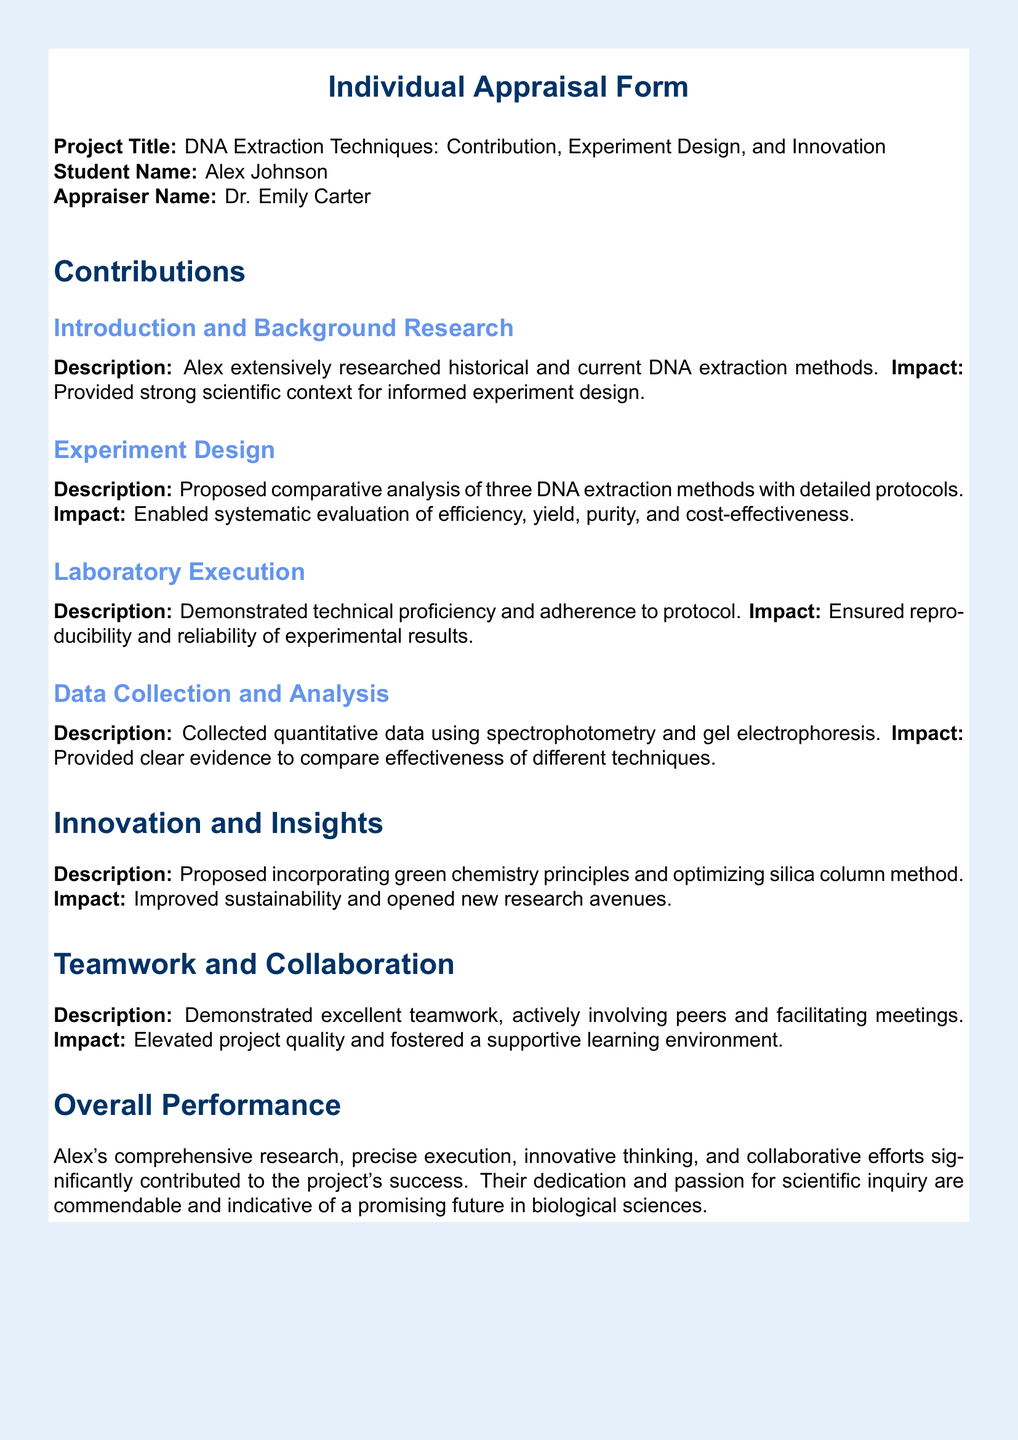What is the project title? The project title is mentioned at the beginning of the document as "DNA Extraction Techniques: Contribution, Experiment Design, and Innovation."
Answer: DNA Extraction Techniques: Contribution, Experiment Design, and Innovation Who is the student name? The document explicitly states the student name as "Alex Johnson."
Answer: Alex Johnson What does the Impact of Laboratory Execution describe? It describes ensuring reproducibility and reliability of experimental results, highlighting the importance of technical proficiency.
Answer: Ensured reproducibility and reliability of experimental results Which principles did Alex propose to incorporate? The document mentions incorporating "green chemistry principles."
Answer: Green chemistry principles Who was the appraiser? The appraiser's name is listed as "Dr. Emily Carter."
Answer: Dr. Emily Carter What was the main innovation suggested in the project? The main innovation mentioned is "optimizing silica column method," indicating an improvement in the extraction technique.
Answer: Optimizing silica column method What types of methods were analyzed in the experiment design? The document states that three DNA extraction methods were proposed for the comparative analysis.
Answer: Three DNA extraction methods What aspect of teamwork did Alex excel in? Alex demonstrated excellent teamwork by actively involving peers and facilitating meetings.
Answer: Actively involving peers and facilitating meetings What was the main impact of data collection and analysis? The impact was providing clear evidence to compare the effectiveness of different techniques used in DNA extraction.
Answer: Provided clear evidence to compare effectiveness of different techniques 